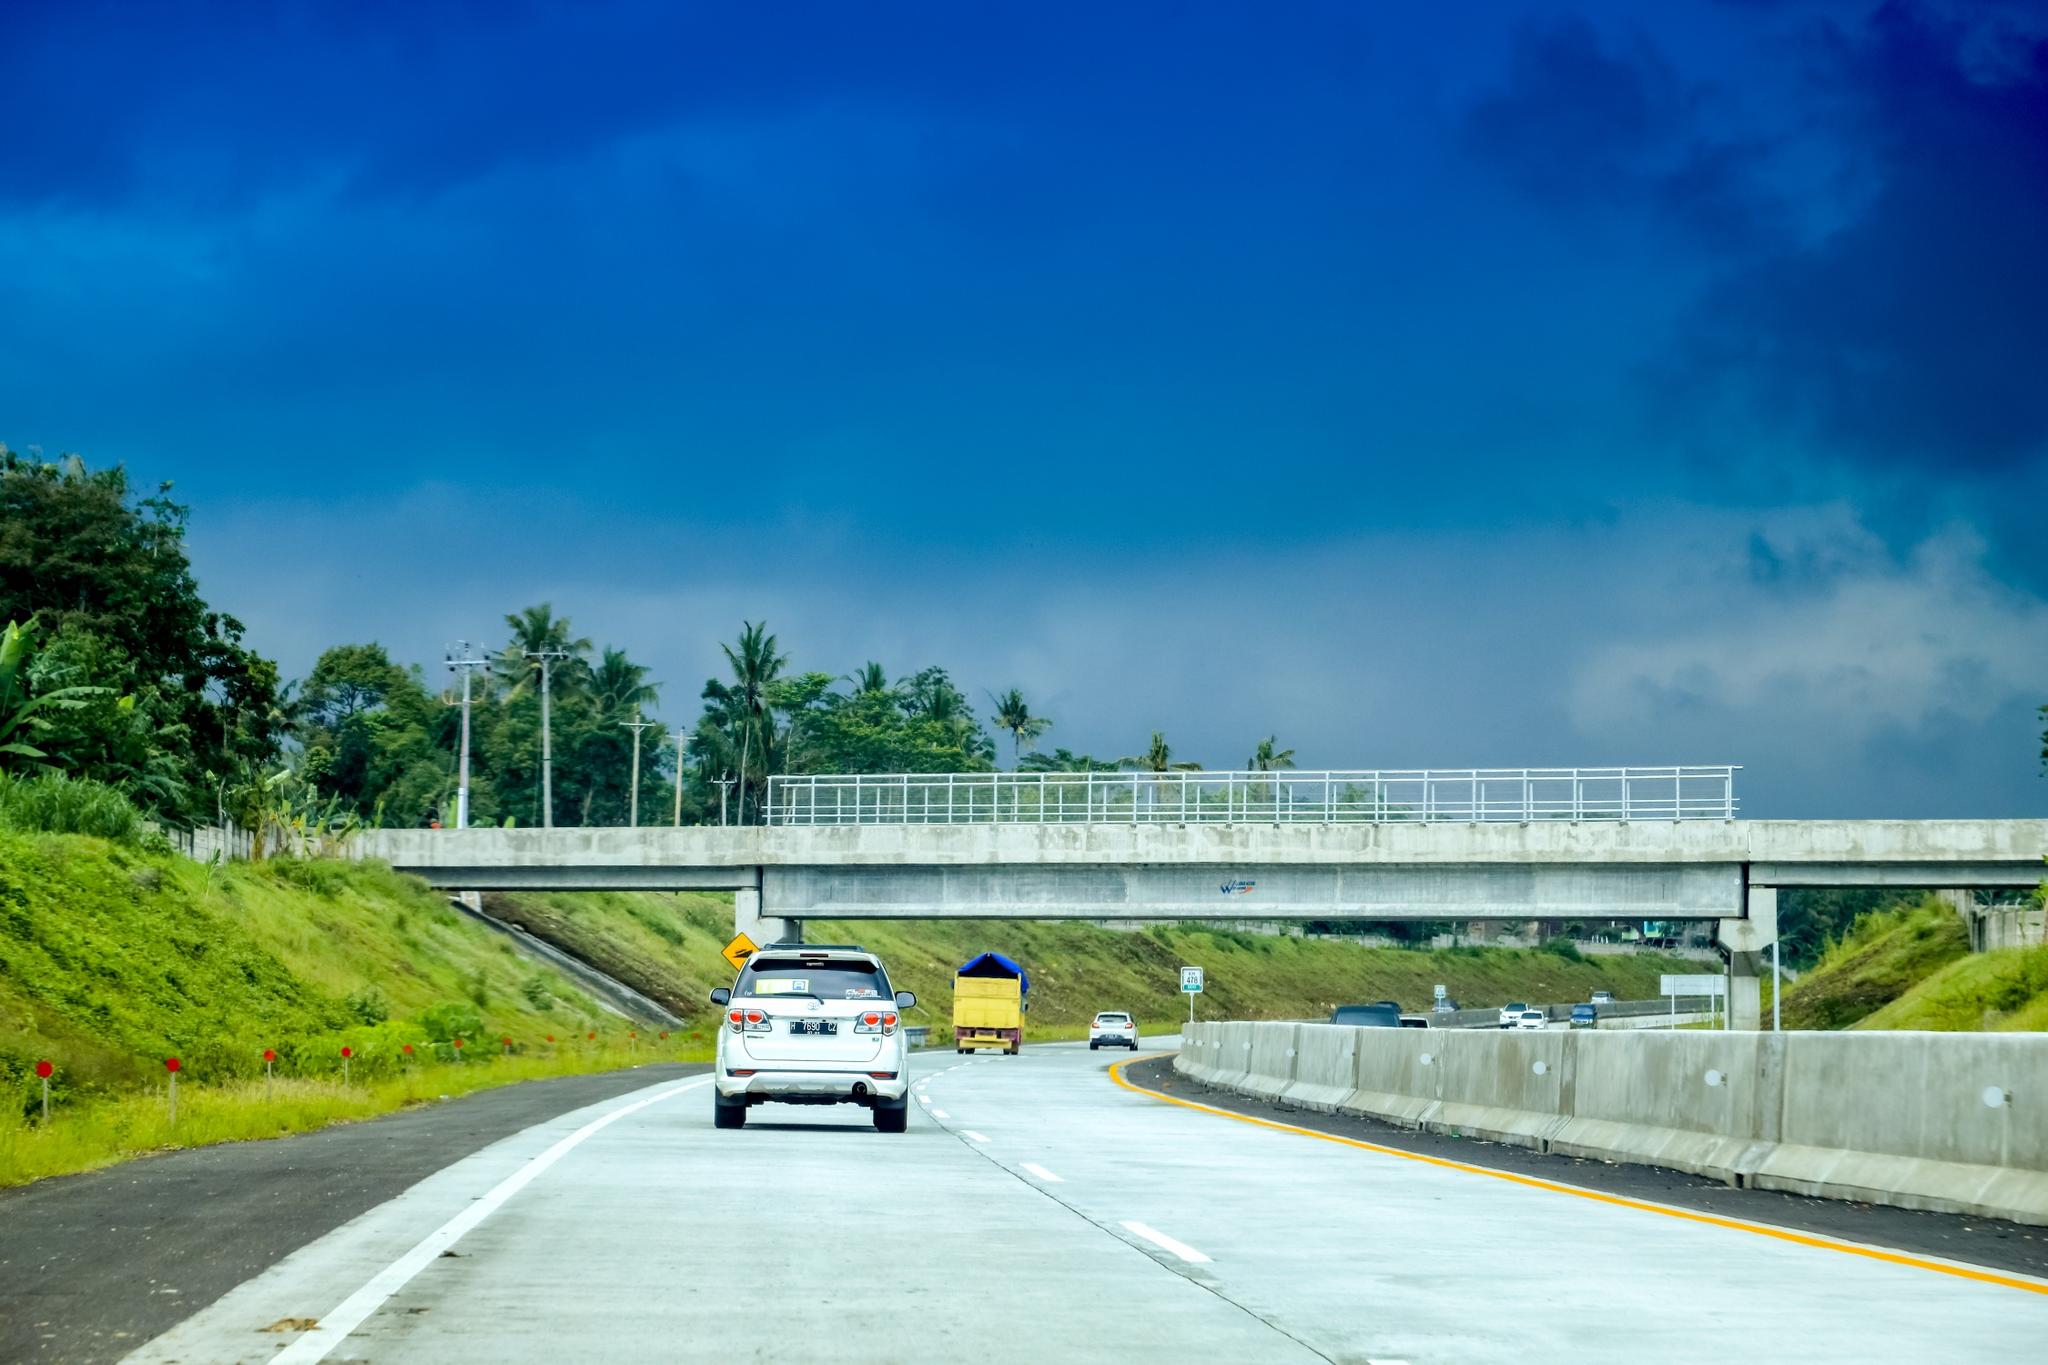What crucial advice would you give to a driver on this highway? For a safe and enjoyable drive on this picturesque highway, make sure your vehicle is well-maintained and fuelled before embarking. Keep an eye out for road signs and adhere to speed limits, as the lush surroundings might conceal sharp turns or sudden stops. Since the scenery is so captivating, take regular breaks at safe spots to enjoy the views rather than getting distracted while driving. Also, it might be wise to carry some local currency, snacks, and a map, in case you decide to explore off the main road and stumble upon charming local markets or hidden gems of nature. 